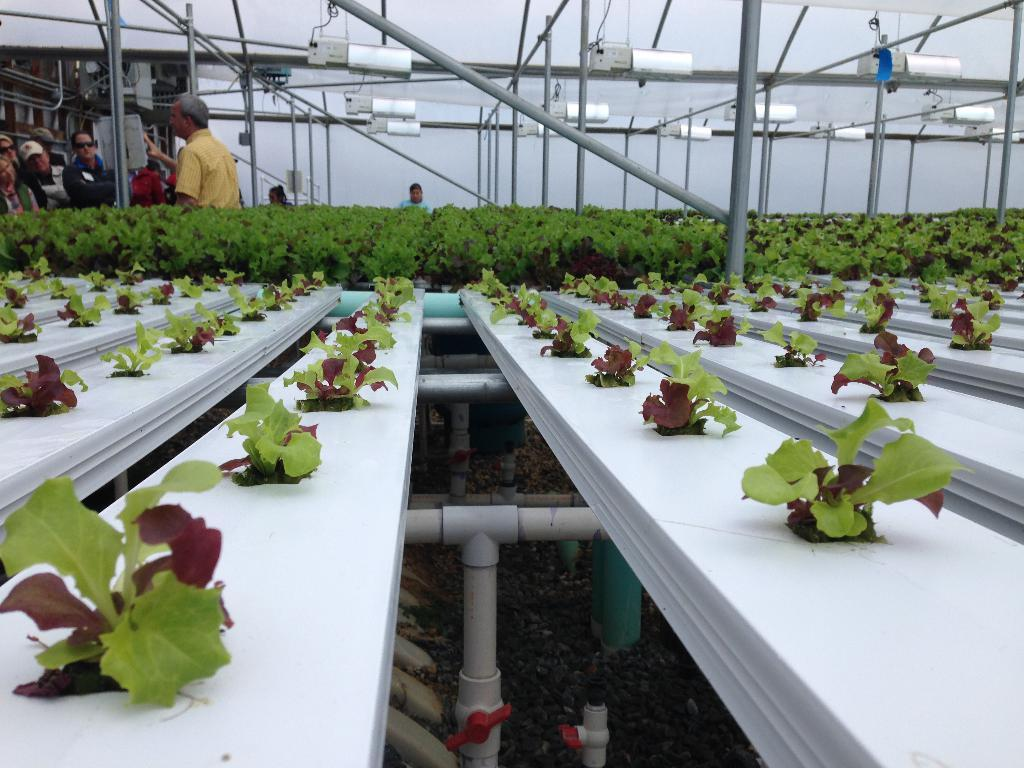Who or what can be seen in the image? There are people in the image. What else is present in the image besides people? There are plants, tables, pipes, and other objects in the image. Can you describe the setting or environment in the image? There is a wall in the background of the image. What type of force is being applied to the leg in the image? There is no leg or force present in the image. 